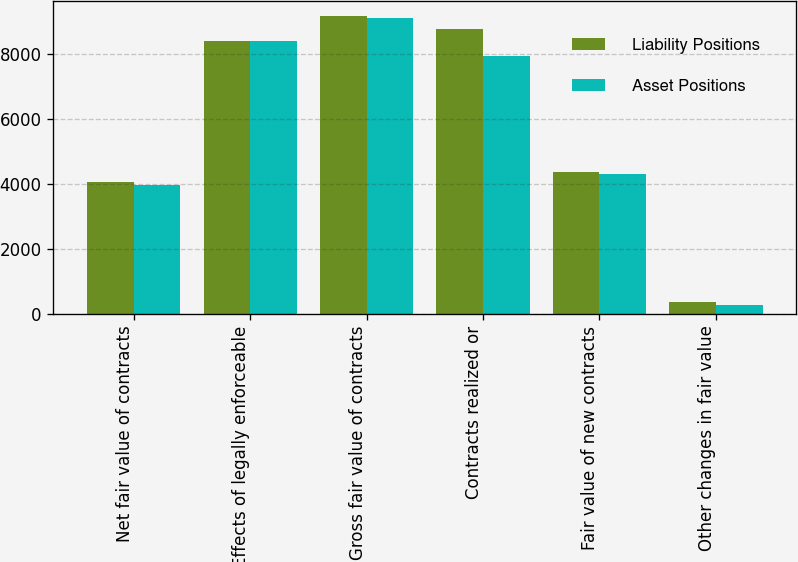<chart> <loc_0><loc_0><loc_500><loc_500><stacked_bar_chart><ecel><fcel>Net fair value of contracts<fcel>Effects of legally enforceable<fcel>Gross fair value of contracts<fcel>Contracts realized or<fcel>Fair value of new contracts<fcel>Other changes in fair value<nl><fcel>Liability Positions<fcel>4041<fcel>8399<fcel>9151<fcel>8755<fcel>4364<fcel>365<nl><fcel>Asset Positions<fcel>3977<fcel>8399<fcel>9087<fcel>7926<fcel>4294<fcel>265<nl></chart> 